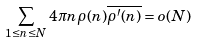Convert formula to latex. <formula><loc_0><loc_0><loc_500><loc_500>\sum _ { 1 \leq n \leq N } 4 \pi n \rho ( n ) \overline { \rho ^ { \prime } ( n ) } = o ( N )</formula> 